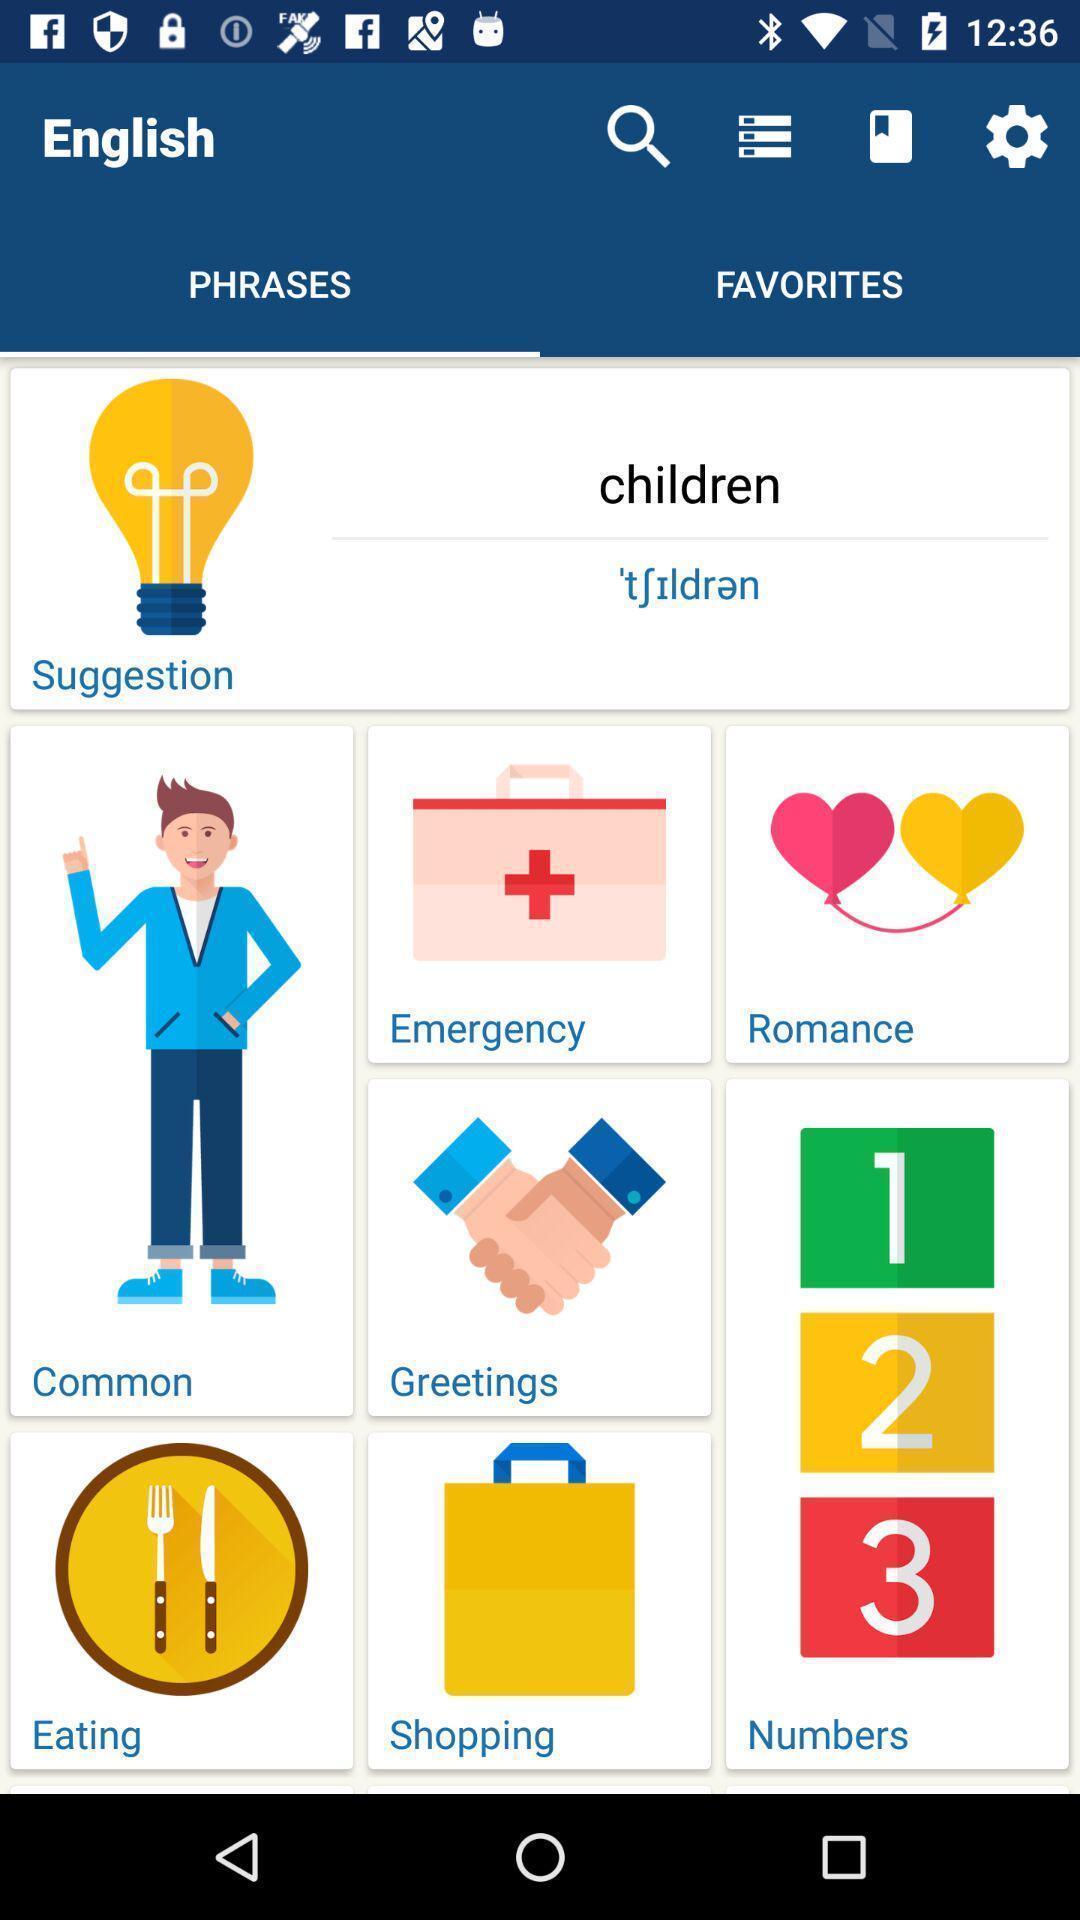What details can you identify in this image? Screen shows multiple options in a learning application. 